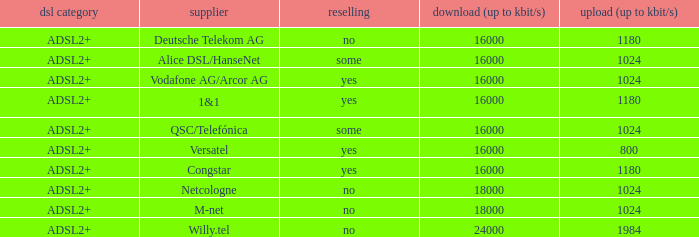What are all the dsl type offered by the M-Net telecom company? ADSL2+. 